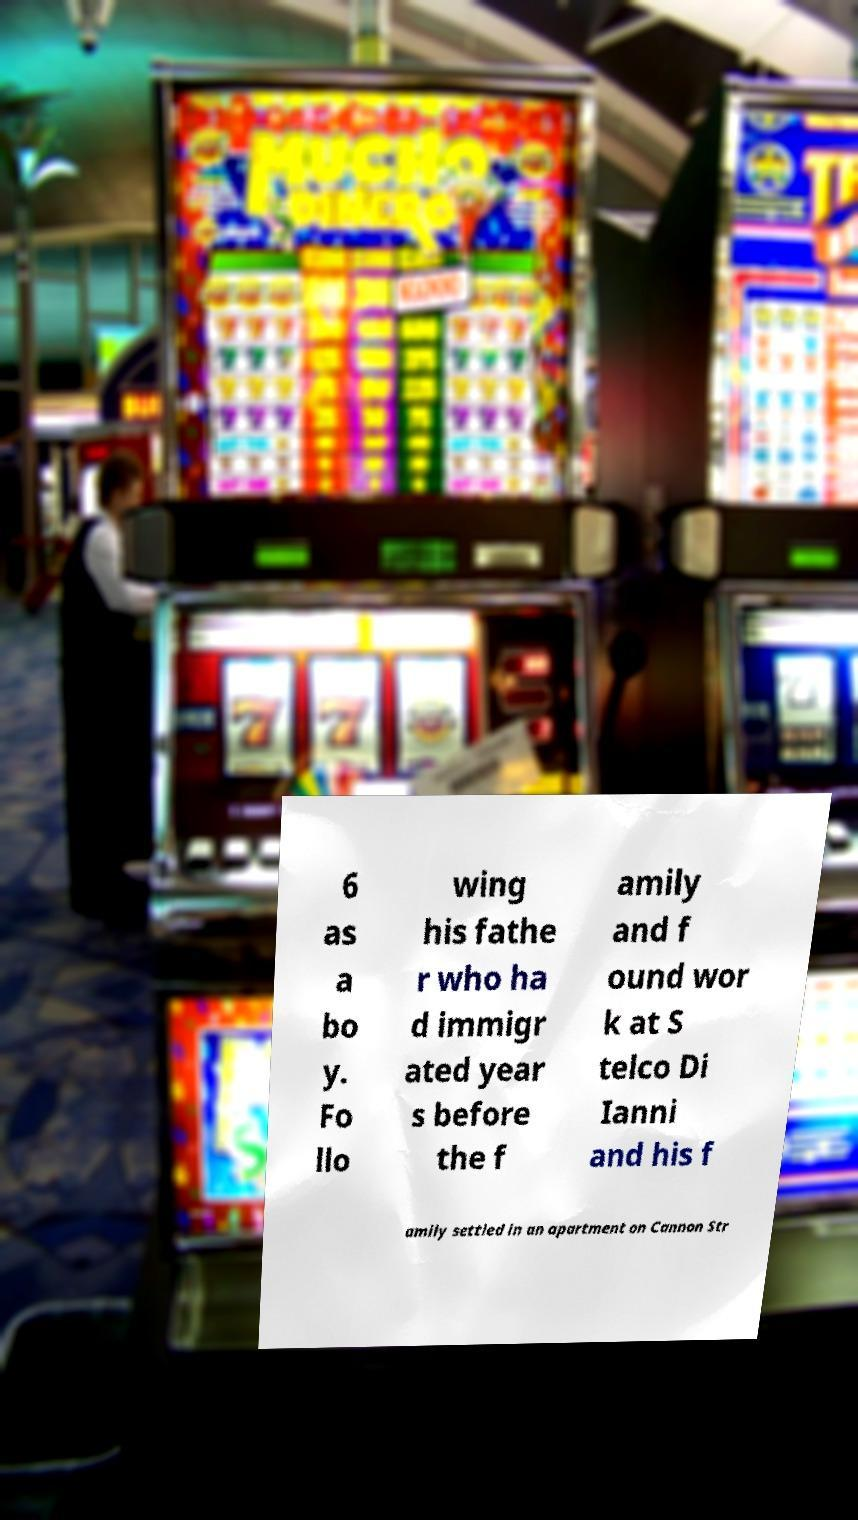There's text embedded in this image that I need extracted. Can you transcribe it verbatim? 6 as a bo y. Fo llo wing his fathe r who ha d immigr ated year s before the f amily and f ound wor k at S telco Di Ianni and his f amily settled in an apartment on Cannon Str 